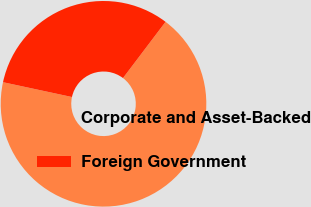Convert chart. <chart><loc_0><loc_0><loc_500><loc_500><pie_chart><fcel>Corporate and Asset-Backed<fcel>Foreign Government<nl><fcel>68.06%<fcel>31.94%<nl></chart> 